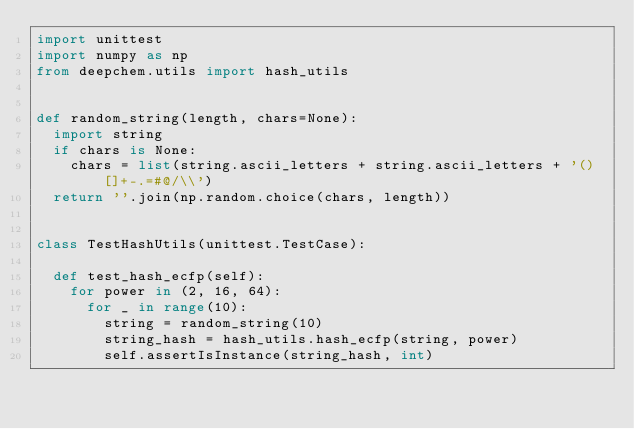Convert code to text. <code><loc_0><loc_0><loc_500><loc_500><_Python_>import unittest
import numpy as np
from deepchem.utils import hash_utils


def random_string(length, chars=None):
  import string
  if chars is None:
    chars = list(string.ascii_letters + string.ascii_letters + '()[]+-.=#@/\\')
  return ''.join(np.random.choice(chars, length))


class TestHashUtils(unittest.TestCase):

  def test_hash_ecfp(self):
    for power in (2, 16, 64):
      for _ in range(10):
        string = random_string(10)
        string_hash = hash_utils.hash_ecfp(string, power)
        self.assertIsInstance(string_hash, int)</code> 